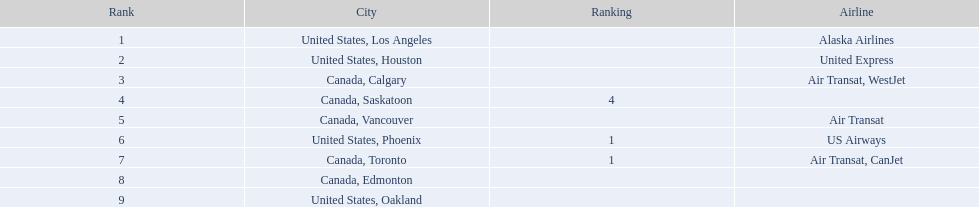What are the cities flown to? United States, Los Angeles, United States, Houston, Canada, Calgary, Canada, Saskatoon, Canada, Vancouver, United States, Phoenix, Canada, Toronto, Canada, Edmonton, United States, Oakland. What number of passengers did pheonix have? 1,829. 